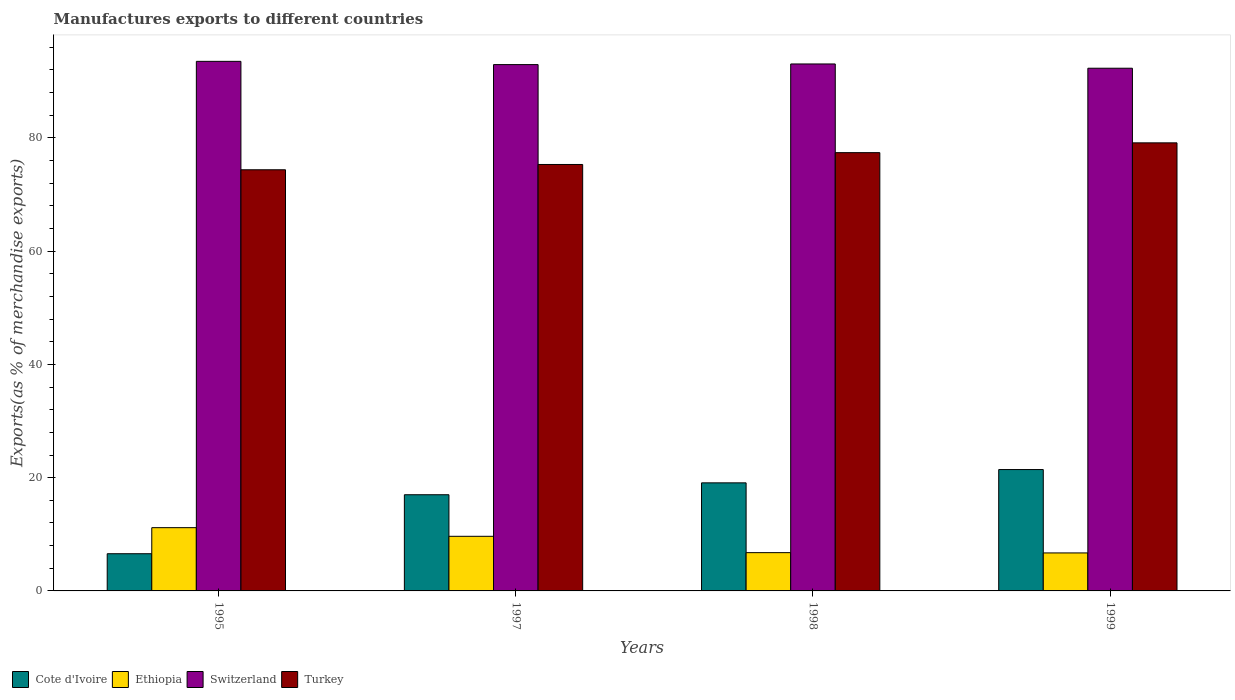Are the number of bars per tick equal to the number of legend labels?
Give a very brief answer. Yes. What is the percentage of exports to different countries in Switzerland in 1997?
Your answer should be very brief. 92.93. Across all years, what is the maximum percentage of exports to different countries in Switzerland?
Keep it short and to the point. 93.51. Across all years, what is the minimum percentage of exports to different countries in Ethiopia?
Give a very brief answer. 6.71. In which year was the percentage of exports to different countries in Switzerland maximum?
Provide a short and direct response. 1995. In which year was the percentage of exports to different countries in Turkey minimum?
Provide a short and direct response. 1995. What is the total percentage of exports to different countries in Cote d'Ivoire in the graph?
Your answer should be very brief. 64.07. What is the difference between the percentage of exports to different countries in Switzerland in 1997 and that in 1999?
Your answer should be very brief. 0.64. What is the difference between the percentage of exports to different countries in Cote d'Ivoire in 1997 and the percentage of exports to different countries in Ethiopia in 1995?
Make the answer very short. 5.81. What is the average percentage of exports to different countries in Turkey per year?
Your answer should be very brief. 76.54. In the year 1995, what is the difference between the percentage of exports to different countries in Switzerland and percentage of exports to different countries in Cote d'Ivoire?
Offer a terse response. 86.94. In how many years, is the percentage of exports to different countries in Turkey greater than 92 %?
Your answer should be very brief. 0. What is the ratio of the percentage of exports to different countries in Ethiopia in 1997 to that in 1999?
Offer a terse response. 1.44. Is the difference between the percentage of exports to different countries in Switzerland in 1997 and 1998 greater than the difference between the percentage of exports to different countries in Cote d'Ivoire in 1997 and 1998?
Your response must be concise. Yes. What is the difference between the highest and the second highest percentage of exports to different countries in Turkey?
Offer a terse response. 1.73. What is the difference between the highest and the lowest percentage of exports to different countries in Turkey?
Provide a succinct answer. 4.75. Is the sum of the percentage of exports to different countries in Turkey in 1997 and 1999 greater than the maximum percentage of exports to different countries in Ethiopia across all years?
Offer a very short reply. Yes. Is it the case that in every year, the sum of the percentage of exports to different countries in Cote d'Ivoire and percentage of exports to different countries in Ethiopia is greater than the sum of percentage of exports to different countries in Turkey and percentage of exports to different countries in Switzerland?
Ensure brevity in your answer.  No. What does the 4th bar from the left in 1997 represents?
Your answer should be very brief. Turkey. What does the 3rd bar from the right in 1995 represents?
Make the answer very short. Ethiopia. How many years are there in the graph?
Give a very brief answer. 4. Does the graph contain any zero values?
Make the answer very short. No. Does the graph contain grids?
Ensure brevity in your answer.  No. Where does the legend appear in the graph?
Offer a very short reply. Bottom left. How many legend labels are there?
Your answer should be very brief. 4. How are the legend labels stacked?
Offer a terse response. Horizontal. What is the title of the graph?
Give a very brief answer. Manufactures exports to different countries. Does "Guam" appear as one of the legend labels in the graph?
Provide a succinct answer. No. What is the label or title of the Y-axis?
Keep it short and to the point. Exports(as % of merchandise exports). What is the Exports(as % of merchandise exports) in Cote d'Ivoire in 1995?
Keep it short and to the point. 6.57. What is the Exports(as % of merchandise exports) of Ethiopia in 1995?
Your answer should be compact. 11.17. What is the Exports(as % of merchandise exports) of Switzerland in 1995?
Your answer should be very brief. 93.51. What is the Exports(as % of merchandise exports) of Turkey in 1995?
Make the answer very short. 74.36. What is the Exports(as % of merchandise exports) in Cote d'Ivoire in 1997?
Offer a very short reply. 16.98. What is the Exports(as % of merchandise exports) in Ethiopia in 1997?
Offer a very short reply. 9.65. What is the Exports(as % of merchandise exports) of Switzerland in 1997?
Provide a succinct answer. 92.93. What is the Exports(as % of merchandise exports) in Turkey in 1997?
Provide a short and direct response. 75.3. What is the Exports(as % of merchandise exports) in Cote d'Ivoire in 1998?
Your answer should be compact. 19.08. What is the Exports(as % of merchandise exports) of Ethiopia in 1998?
Your answer should be compact. 6.76. What is the Exports(as % of merchandise exports) of Switzerland in 1998?
Your answer should be compact. 93.05. What is the Exports(as % of merchandise exports) of Turkey in 1998?
Make the answer very short. 77.39. What is the Exports(as % of merchandise exports) of Cote d'Ivoire in 1999?
Your answer should be compact. 21.43. What is the Exports(as % of merchandise exports) of Ethiopia in 1999?
Provide a succinct answer. 6.71. What is the Exports(as % of merchandise exports) in Switzerland in 1999?
Your answer should be compact. 92.3. What is the Exports(as % of merchandise exports) of Turkey in 1999?
Offer a very short reply. 79.12. Across all years, what is the maximum Exports(as % of merchandise exports) of Cote d'Ivoire?
Your answer should be compact. 21.43. Across all years, what is the maximum Exports(as % of merchandise exports) in Ethiopia?
Your answer should be very brief. 11.17. Across all years, what is the maximum Exports(as % of merchandise exports) of Switzerland?
Offer a very short reply. 93.51. Across all years, what is the maximum Exports(as % of merchandise exports) in Turkey?
Provide a succinct answer. 79.12. Across all years, what is the minimum Exports(as % of merchandise exports) of Cote d'Ivoire?
Keep it short and to the point. 6.57. Across all years, what is the minimum Exports(as % of merchandise exports) of Ethiopia?
Ensure brevity in your answer.  6.71. Across all years, what is the minimum Exports(as % of merchandise exports) of Switzerland?
Your answer should be very brief. 92.3. Across all years, what is the minimum Exports(as % of merchandise exports) in Turkey?
Make the answer very short. 74.36. What is the total Exports(as % of merchandise exports) in Cote d'Ivoire in the graph?
Your response must be concise. 64.07. What is the total Exports(as % of merchandise exports) in Ethiopia in the graph?
Provide a succinct answer. 34.28. What is the total Exports(as % of merchandise exports) of Switzerland in the graph?
Provide a succinct answer. 371.79. What is the total Exports(as % of merchandise exports) in Turkey in the graph?
Give a very brief answer. 306.17. What is the difference between the Exports(as % of merchandise exports) in Cote d'Ivoire in 1995 and that in 1997?
Ensure brevity in your answer.  -10.42. What is the difference between the Exports(as % of merchandise exports) in Ethiopia in 1995 and that in 1997?
Your response must be concise. 1.53. What is the difference between the Exports(as % of merchandise exports) in Switzerland in 1995 and that in 1997?
Provide a short and direct response. 0.57. What is the difference between the Exports(as % of merchandise exports) of Turkey in 1995 and that in 1997?
Offer a very short reply. -0.93. What is the difference between the Exports(as % of merchandise exports) in Cote d'Ivoire in 1995 and that in 1998?
Your answer should be very brief. -12.51. What is the difference between the Exports(as % of merchandise exports) of Ethiopia in 1995 and that in 1998?
Offer a very short reply. 4.41. What is the difference between the Exports(as % of merchandise exports) in Switzerland in 1995 and that in 1998?
Keep it short and to the point. 0.46. What is the difference between the Exports(as % of merchandise exports) of Turkey in 1995 and that in 1998?
Your answer should be compact. -3.03. What is the difference between the Exports(as % of merchandise exports) of Cote d'Ivoire in 1995 and that in 1999?
Offer a terse response. -14.86. What is the difference between the Exports(as % of merchandise exports) in Ethiopia in 1995 and that in 1999?
Provide a succinct answer. 4.46. What is the difference between the Exports(as % of merchandise exports) of Switzerland in 1995 and that in 1999?
Ensure brevity in your answer.  1.21. What is the difference between the Exports(as % of merchandise exports) in Turkey in 1995 and that in 1999?
Give a very brief answer. -4.75. What is the difference between the Exports(as % of merchandise exports) in Cote d'Ivoire in 1997 and that in 1998?
Provide a short and direct response. -2.1. What is the difference between the Exports(as % of merchandise exports) of Ethiopia in 1997 and that in 1998?
Make the answer very short. 2.89. What is the difference between the Exports(as % of merchandise exports) of Switzerland in 1997 and that in 1998?
Provide a succinct answer. -0.12. What is the difference between the Exports(as % of merchandise exports) of Turkey in 1997 and that in 1998?
Give a very brief answer. -2.09. What is the difference between the Exports(as % of merchandise exports) in Cote d'Ivoire in 1997 and that in 1999?
Offer a terse response. -4.45. What is the difference between the Exports(as % of merchandise exports) in Ethiopia in 1997 and that in 1999?
Provide a short and direct response. 2.94. What is the difference between the Exports(as % of merchandise exports) of Switzerland in 1997 and that in 1999?
Ensure brevity in your answer.  0.64. What is the difference between the Exports(as % of merchandise exports) in Turkey in 1997 and that in 1999?
Make the answer very short. -3.82. What is the difference between the Exports(as % of merchandise exports) of Cote d'Ivoire in 1998 and that in 1999?
Keep it short and to the point. -2.35. What is the difference between the Exports(as % of merchandise exports) in Ethiopia in 1998 and that in 1999?
Your answer should be very brief. 0.05. What is the difference between the Exports(as % of merchandise exports) in Switzerland in 1998 and that in 1999?
Your answer should be very brief. 0.75. What is the difference between the Exports(as % of merchandise exports) in Turkey in 1998 and that in 1999?
Keep it short and to the point. -1.73. What is the difference between the Exports(as % of merchandise exports) in Cote d'Ivoire in 1995 and the Exports(as % of merchandise exports) in Ethiopia in 1997?
Make the answer very short. -3.08. What is the difference between the Exports(as % of merchandise exports) in Cote d'Ivoire in 1995 and the Exports(as % of merchandise exports) in Switzerland in 1997?
Provide a succinct answer. -86.37. What is the difference between the Exports(as % of merchandise exports) of Cote d'Ivoire in 1995 and the Exports(as % of merchandise exports) of Turkey in 1997?
Provide a short and direct response. -68.73. What is the difference between the Exports(as % of merchandise exports) in Ethiopia in 1995 and the Exports(as % of merchandise exports) in Switzerland in 1997?
Offer a very short reply. -81.76. What is the difference between the Exports(as % of merchandise exports) of Ethiopia in 1995 and the Exports(as % of merchandise exports) of Turkey in 1997?
Offer a terse response. -64.13. What is the difference between the Exports(as % of merchandise exports) of Switzerland in 1995 and the Exports(as % of merchandise exports) of Turkey in 1997?
Provide a succinct answer. 18.21. What is the difference between the Exports(as % of merchandise exports) of Cote d'Ivoire in 1995 and the Exports(as % of merchandise exports) of Ethiopia in 1998?
Provide a succinct answer. -0.19. What is the difference between the Exports(as % of merchandise exports) of Cote d'Ivoire in 1995 and the Exports(as % of merchandise exports) of Switzerland in 1998?
Your response must be concise. -86.48. What is the difference between the Exports(as % of merchandise exports) of Cote d'Ivoire in 1995 and the Exports(as % of merchandise exports) of Turkey in 1998?
Your response must be concise. -70.82. What is the difference between the Exports(as % of merchandise exports) in Ethiopia in 1995 and the Exports(as % of merchandise exports) in Switzerland in 1998?
Keep it short and to the point. -81.88. What is the difference between the Exports(as % of merchandise exports) of Ethiopia in 1995 and the Exports(as % of merchandise exports) of Turkey in 1998?
Your answer should be compact. -66.22. What is the difference between the Exports(as % of merchandise exports) of Switzerland in 1995 and the Exports(as % of merchandise exports) of Turkey in 1998?
Your answer should be very brief. 16.12. What is the difference between the Exports(as % of merchandise exports) in Cote d'Ivoire in 1995 and the Exports(as % of merchandise exports) in Ethiopia in 1999?
Ensure brevity in your answer.  -0.14. What is the difference between the Exports(as % of merchandise exports) in Cote d'Ivoire in 1995 and the Exports(as % of merchandise exports) in Switzerland in 1999?
Your answer should be compact. -85.73. What is the difference between the Exports(as % of merchandise exports) in Cote d'Ivoire in 1995 and the Exports(as % of merchandise exports) in Turkey in 1999?
Your response must be concise. -72.55. What is the difference between the Exports(as % of merchandise exports) in Ethiopia in 1995 and the Exports(as % of merchandise exports) in Switzerland in 1999?
Provide a succinct answer. -81.13. What is the difference between the Exports(as % of merchandise exports) of Ethiopia in 1995 and the Exports(as % of merchandise exports) of Turkey in 1999?
Provide a short and direct response. -67.95. What is the difference between the Exports(as % of merchandise exports) of Switzerland in 1995 and the Exports(as % of merchandise exports) of Turkey in 1999?
Provide a short and direct response. 14.39. What is the difference between the Exports(as % of merchandise exports) in Cote d'Ivoire in 1997 and the Exports(as % of merchandise exports) in Ethiopia in 1998?
Keep it short and to the point. 10.23. What is the difference between the Exports(as % of merchandise exports) of Cote d'Ivoire in 1997 and the Exports(as % of merchandise exports) of Switzerland in 1998?
Your answer should be compact. -76.07. What is the difference between the Exports(as % of merchandise exports) of Cote d'Ivoire in 1997 and the Exports(as % of merchandise exports) of Turkey in 1998?
Provide a short and direct response. -60.41. What is the difference between the Exports(as % of merchandise exports) of Ethiopia in 1997 and the Exports(as % of merchandise exports) of Switzerland in 1998?
Your answer should be compact. -83.4. What is the difference between the Exports(as % of merchandise exports) in Ethiopia in 1997 and the Exports(as % of merchandise exports) in Turkey in 1998?
Make the answer very short. -67.74. What is the difference between the Exports(as % of merchandise exports) in Switzerland in 1997 and the Exports(as % of merchandise exports) in Turkey in 1998?
Make the answer very short. 15.54. What is the difference between the Exports(as % of merchandise exports) of Cote d'Ivoire in 1997 and the Exports(as % of merchandise exports) of Ethiopia in 1999?
Your response must be concise. 10.28. What is the difference between the Exports(as % of merchandise exports) in Cote d'Ivoire in 1997 and the Exports(as % of merchandise exports) in Switzerland in 1999?
Offer a terse response. -75.31. What is the difference between the Exports(as % of merchandise exports) of Cote d'Ivoire in 1997 and the Exports(as % of merchandise exports) of Turkey in 1999?
Provide a succinct answer. -62.13. What is the difference between the Exports(as % of merchandise exports) of Ethiopia in 1997 and the Exports(as % of merchandise exports) of Switzerland in 1999?
Make the answer very short. -82.65. What is the difference between the Exports(as % of merchandise exports) of Ethiopia in 1997 and the Exports(as % of merchandise exports) of Turkey in 1999?
Provide a succinct answer. -69.47. What is the difference between the Exports(as % of merchandise exports) of Switzerland in 1997 and the Exports(as % of merchandise exports) of Turkey in 1999?
Your response must be concise. 13.82. What is the difference between the Exports(as % of merchandise exports) of Cote d'Ivoire in 1998 and the Exports(as % of merchandise exports) of Ethiopia in 1999?
Offer a very short reply. 12.37. What is the difference between the Exports(as % of merchandise exports) of Cote d'Ivoire in 1998 and the Exports(as % of merchandise exports) of Switzerland in 1999?
Your response must be concise. -73.21. What is the difference between the Exports(as % of merchandise exports) in Cote d'Ivoire in 1998 and the Exports(as % of merchandise exports) in Turkey in 1999?
Offer a terse response. -60.04. What is the difference between the Exports(as % of merchandise exports) of Ethiopia in 1998 and the Exports(as % of merchandise exports) of Switzerland in 1999?
Ensure brevity in your answer.  -85.54. What is the difference between the Exports(as % of merchandise exports) of Ethiopia in 1998 and the Exports(as % of merchandise exports) of Turkey in 1999?
Your response must be concise. -72.36. What is the difference between the Exports(as % of merchandise exports) in Switzerland in 1998 and the Exports(as % of merchandise exports) in Turkey in 1999?
Ensure brevity in your answer.  13.93. What is the average Exports(as % of merchandise exports) in Cote d'Ivoire per year?
Make the answer very short. 16.02. What is the average Exports(as % of merchandise exports) of Ethiopia per year?
Your answer should be very brief. 8.57. What is the average Exports(as % of merchandise exports) of Switzerland per year?
Provide a succinct answer. 92.95. What is the average Exports(as % of merchandise exports) in Turkey per year?
Offer a terse response. 76.54. In the year 1995, what is the difference between the Exports(as % of merchandise exports) in Cote d'Ivoire and Exports(as % of merchandise exports) in Ethiopia?
Make the answer very short. -4.6. In the year 1995, what is the difference between the Exports(as % of merchandise exports) of Cote d'Ivoire and Exports(as % of merchandise exports) of Switzerland?
Your response must be concise. -86.94. In the year 1995, what is the difference between the Exports(as % of merchandise exports) of Cote d'Ivoire and Exports(as % of merchandise exports) of Turkey?
Your response must be concise. -67.8. In the year 1995, what is the difference between the Exports(as % of merchandise exports) of Ethiopia and Exports(as % of merchandise exports) of Switzerland?
Your answer should be compact. -82.34. In the year 1995, what is the difference between the Exports(as % of merchandise exports) of Ethiopia and Exports(as % of merchandise exports) of Turkey?
Your answer should be compact. -63.19. In the year 1995, what is the difference between the Exports(as % of merchandise exports) in Switzerland and Exports(as % of merchandise exports) in Turkey?
Ensure brevity in your answer.  19.14. In the year 1997, what is the difference between the Exports(as % of merchandise exports) in Cote d'Ivoire and Exports(as % of merchandise exports) in Ethiopia?
Provide a short and direct response. 7.34. In the year 1997, what is the difference between the Exports(as % of merchandise exports) in Cote d'Ivoire and Exports(as % of merchandise exports) in Switzerland?
Offer a terse response. -75.95. In the year 1997, what is the difference between the Exports(as % of merchandise exports) in Cote d'Ivoire and Exports(as % of merchandise exports) in Turkey?
Offer a terse response. -58.31. In the year 1997, what is the difference between the Exports(as % of merchandise exports) of Ethiopia and Exports(as % of merchandise exports) of Switzerland?
Your answer should be compact. -83.29. In the year 1997, what is the difference between the Exports(as % of merchandise exports) of Ethiopia and Exports(as % of merchandise exports) of Turkey?
Give a very brief answer. -65.65. In the year 1997, what is the difference between the Exports(as % of merchandise exports) in Switzerland and Exports(as % of merchandise exports) in Turkey?
Ensure brevity in your answer.  17.64. In the year 1998, what is the difference between the Exports(as % of merchandise exports) of Cote d'Ivoire and Exports(as % of merchandise exports) of Ethiopia?
Ensure brevity in your answer.  12.32. In the year 1998, what is the difference between the Exports(as % of merchandise exports) of Cote d'Ivoire and Exports(as % of merchandise exports) of Switzerland?
Keep it short and to the point. -73.97. In the year 1998, what is the difference between the Exports(as % of merchandise exports) in Cote d'Ivoire and Exports(as % of merchandise exports) in Turkey?
Provide a short and direct response. -58.31. In the year 1998, what is the difference between the Exports(as % of merchandise exports) in Ethiopia and Exports(as % of merchandise exports) in Switzerland?
Your answer should be compact. -86.29. In the year 1998, what is the difference between the Exports(as % of merchandise exports) of Ethiopia and Exports(as % of merchandise exports) of Turkey?
Keep it short and to the point. -70.63. In the year 1998, what is the difference between the Exports(as % of merchandise exports) in Switzerland and Exports(as % of merchandise exports) in Turkey?
Your response must be concise. 15.66. In the year 1999, what is the difference between the Exports(as % of merchandise exports) in Cote d'Ivoire and Exports(as % of merchandise exports) in Ethiopia?
Offer a terse response. 14.72. In the year 1999, what is the difference between the Exports(as % of merchandise exports) in Cote d'Ivoire and Exports(as % of merchandise exports) in Switzerland?
Provide a short and direct response. -70.87. In the year 1999, what is the difference between the Exports(as % of merchandise exports) of Cote d'Ivoire and Exports(as % of merchandise exports) of Turkey?
Offer a very short reply. -57.69. In the year 1999, what is the difference between the Exports(as % of merchandise exports) in Ethiopia and Exports(as % of merchandise exports) in Switzerland?
Your answer should be very brief. -85.59. In the year 1999, what is the difference between the Exports(as % of merchandise exports) in Ethiopia and Exports(as % of merchandise exports) in Turkey?
Make the answer very short. -72.41. In the year 1999, what is the difference between the Exports(as % of merchandise exports) of Switzerland and Exports(as % of merchandise exports) of Turkey?
Your answer should be very brief. 13.18. What is the ratio of the Exports(as % of merchandise exports) in Cote d'Ivoire in 1995 to that in 1997?
Offer a terse response. 0.39. What is the ratio of the Exports(as % of merchandise exports) in Ethiopia in 1995 to that in 1997?
Your answer should be compact. 1.16. What is the ratio of the Exports(as % of merchandise exports) of Switzerland in 1995 to that in 1997?
Make the answer very short. 1.01. What is the ratio of the Exports(as % of merchandise exports) in Turkey in 1995 to that in 1997?
Keep it short and to the point. 0.99. What is the ratio of the Exports(as % of merchandise exports) in Cote d'Ivoire in 1995 to that in 1998?
Make the answer very short. 0.34. What is the ratio of the Exports(as % of merchandise exports) of Ethiopia in 1995 to that in 1998?
Make the answer very short. 1.65. What is the ratio of the Exports(as % of merchandise exports) of Switzerland in 1995 to that in 1998?
Provide a succinct answer. 1. What is the ratio of the Exports(as % of merchandise exports) in Turkey in 1995 to that in 1998?
Your answer should be very brief. 0.96. What is the ratio of the Exports(as % of merchandise exports) in Cote d'Ivoire in 1995 to that in 1999?
Give a very brief answer. 0.31. What is the ratio of the Exports(as % of merchandise exports) of Ethiopia in 1995 to that in 1999?
Make the answer very short. 1.67. What is the ratio of the Exports(as % of merchandise exports) in Switzerland in 1995 to that in 1999?
Give a very brief answer. 1.01. What is the ratio of the Exports(as % of merchandise exports) in Turkey in 1995 to that in 1999?
Provide a short and direct response. 0.94. What is the ratio of the Exports(as % of merchandise exports) of Cote d'Ivoire in 1997 to that in 1998?
Provide a succinct answer. 0.89. What is the ratio of the Exports(as % of merchandise exports) in Ethiopia in 1997 to that in 1998?
Your answer should be compact. 1.43. What is the ratio of the Exports(as % of merchandise exports) in Turkey in 1997 to that in 1998?
Your answer should be very brief. 0.97. What is the ratio of the Exports(as % of merchandise exports) in Cote d'Ivoire in 1997 to that in 1999?
Your response must be concise. 0.79. What is the ratio of the Exports(as % of merchandise exports) in Ethiopia in 1997 to that in 1999?
Your response must be concise. 1.44. What is the ratio of the Exports(as % of merchandise exports) of Turkey in 1997 to that in 1999?
Your answer should be compact. 0.95. What is the ratio of the Exports(as % of merchandise exports) in Cote d'Ivoire in 1998 to that in 1999?
Provide a succinct answer. 0.89. What is the ratio of the Exports(as % of merchandise exports) of Ethiopia in 1998 to that in 1999?
Give a very brief answer. 1.01. What is the ratio of the Exports(as % of merchandise exports) in Switzerland in 1998 to that in 1999?
Keep it short and to the point. 1.01. What is the ratio of the Exports(as % of merchandise exports) of Turkey in 1998 to that in 1999?
Give a very brief answer. 0.98. What is the difference between the highest and the second highest Exports(as % of merchandise exports) of Cote d'Ivoire?
Ensure brevity in your answer.  2.35. What is the difference between the highest and the second highest Exports(as % of merchandise exports) in Ethiopia?
Keep it short and to the point. 1.53. What is the difference between the highest and the second highest Exports(as % of merchandise exports) in Switzerland?
Provide a succinct answer. 0.46. What is the difference between the highest and the second highest Exports(as % of merchandise exports) of Turkey?
Keep it short and to the point. 1.73. What is the difference between the highest and the lowest Exports(as % of merchandise exports) in Cote d'Ivoire?
Give a very brief answer. 14.86. What is the difference between the highest and the lowest Exports(as % of merchandise exports) in Ethiopia?
Provide a succinct answer. 4.46. What is the difference between the highest and the lowest Exports(as % of merchandise exports) in Switzerland?
Your answer should be very brief. 1.21. What is the difference between the highest and the lowest Exports(as % of merchandise exports) in Turkey?
Provide a short and direct response. 4.75. 